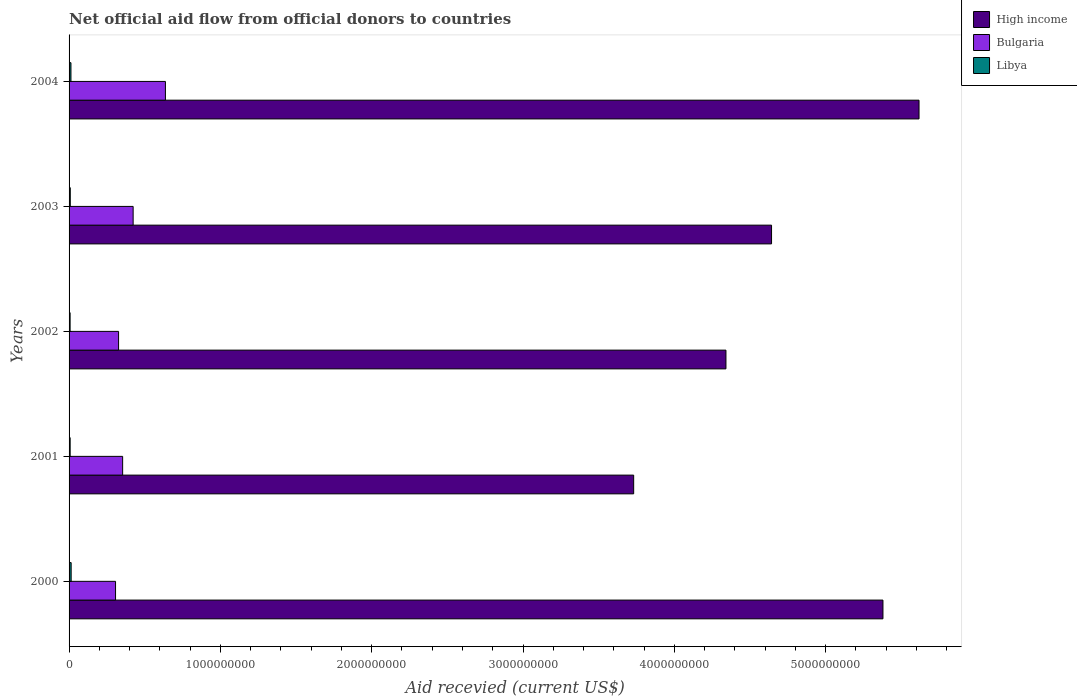How many different coloured bars are there?
Keep it short and to the point. 3. Are the number of bars on each tick of the Y-axis equal?
Ensure brevity in your answer.  Yes. How many bars are there on the 5th tick from the top?
Provide a succinct answer. 3. How many bars are there on the 3rd tick from the bottom?
Your response must be concise. 3. What is the label of the 5th group of bars from the top?
Provide a short and direct response. 2000. What is the total aid received in Bulgaria in 2000?
Make the answer very short. 3.07e+08. Across all years, what is the maximum total aid received in Bulgaria?
Make the answer very short. 6.37e+08. Across all years, what is the minimum total aid received in Libya?
Offer a terse response. 6.88e+06. In which year was the total aid received in Libya minimum?
Your response must be concise. 2002. What is the total total aid received in Libya in the graph?
Offer a terse response. 4.82e+07. What is the difference between the total aid received in High income in 2000 and that in 2004?
Offer a terse response. -2.38e+08. What is the difference between the total aid received in High income in 2001 and the total aid received in Bulgaria in 2002?
Offer a very short reply. 3.40e+09. What is the average total aid received in High income per year?
Provide a succinct answer. 4.74e+09. In the year 2004, what is the difference between the total aid received in Libya and total aid received in High income?
Make the answer very short. -5.60e+09. What is the ratio of the total aid received in High income in 2003 to that in 2004?
Provide a succinct answer. 0.83. Is the difference between the total aid received in Libya in 2002 and 2004 greater than the difference between the total aid received in High income in 2002 and 2004?
Your response must be concise. Yes. What is the difference between the highest and the second highest total aid received in Bulgaria?
Make the answer very short. 2.13e+08. What is the difference between the highest and the lowest total aid received in High income?
Keep it short and to the point. 1.89e+09. In how many years, is the total aid received in High income greater than the average total aid received in High income taken over all years?
Your answer should be very brief. 2. Is the sum of the total aid received in Libya in 2000 and 2003 greater than the maximum total aid received in High income across all years?
Your answer should be compact. No. What does the 1st bar from the top in 2002 represents?
Provide a succinct answer. Libya. What does the 2nd bar from the bottom in 2004 represents?
Your answer should be compact. Bulgaria. Are all the bars in the graph horizontal?
Offer a very short reply. Yes. How many years are there in the graph?
Keep it short and to the point. 5. What is the difference between two consecutive major ticks on the X-axis?
Offer a terse response. 1.00e+09. Are the values on the major ticks of X-axis written in scientific E-notation?
Your answer should be very brief. No. Does the graph contain any zero values?
Give a very brief answer. No. Does the graph contain grids?
Give a very brief answer. No. Where does the legend appear in the graph?
Offer a terse response. Top right. How are the legend labels stacked?
Provide a short and direct response. Vertical. What is the title of the graph?
Your answer should be very brief. Net official aid flow from official donors to countries. Does "South Africa" appear as one of the legend labels in the graph?
Give a very brief answer. No. What is the label or title of the X-axis?
Your response must be concise. Aid recevied (current US$). What is the label or title of the Y-axis?
Your answer should be compact. Years. What is the Aid recevied (current US$) in High income in 2000?
Ensure brevity in your answer.  5.38e+09. What is the Aid recevied (current US$) of Bulgaria in 2000?
Provide a succinct answer. 3.07e+08. What is the Aid recevied (current US$) of Libya in 2000?
Provide a succinct answer. 1.38e+07. What is the Aid recevied (current US$) of High income in 2001?
Offer a very short reply. 3.73e+09. What is the Aid recevied (current US$) in Bulgaria in 2001?
Offer a terse response. 3.54e+08. What is the Aid recevied (current US$) of Libya in 2001?
Ensure brevity in your answer.  7.14e+06. What is the Aid recevied (current US$) of High income in 2002?
Offer a very short reply. 4.34e+09. What is the Aid recevied (current US$) of Bulgaria in 2002?
Offer a terse response. 3.27e+08. What is the Aid recevied (current US$) of Libya in 2002?
Provide a succinct answer. 6.88e+06. What is the Aid recevied (current US$) of High income in 2003?
Provide a succinct answer. 4.64e+09. What is the Aid recevied (current US$) of Bulgaria in 2003?
Your answer should be compact. 4.23e+08. What is the Aid recevied (current US$) in Libya in 2003?
Ensure brevity in your answer.  7.95e+06. What is the Aid recevied (current US$) of High income in 2004?
Provide a succinct answer. 5.62e+09. What is the Aid recevied (current US$) of Bulgaria in 2004?
Provide a short and direct response. 6.37e+08. What is the Aid recevied (current US$) in Libya in 2004?
Provide a succinct answer. 1.24e+07. Across all years, what is the maximum Aid recevied (current US$) in High income?
Provide a succinct answer. 5.62e+09. Across all years, what is the maximum Aid recevied (current US$) in Bulgaria?
Offer a very short reply. 6.37e+08. Across all years, what is the maximum Aid recevied (current US$) of Libya?
Provide a short and direct response. 1.38e+07. Across all years, what is the minimum Aid recevied (current US$) in High income?
Your answer should be compact. 3.73e+09. Across all years, what is the minimum Aid recevied (current US$) in Bulgaria?
Provide a succinct answer. 3.07e+08. Across all years, what is the minimum Aid recevied (current US$) of Libya?
Ensure brevity in your answer.  6.88e+06. What is the total Aid recevied (current US$) in High income in the graph?
Your answer should be very brief. 2.37e+1. What is the total Aid recevied (current US$) of Bulgaria in the graph?
Ensure brevity in your answer.  2.05e+09. What is the total Aid recevied (current US$) in Libya in the graph?
Provide a succinct answer. 4.82e+07. What is the difference between the Aid recevied (current US$) in High income in 2000 and that in 2001?
Provide a succinct answer. 1.65e+09. What is the difference between the Aid recevied (current US$) in Bulgaria in 2000 and that in 2001?
Make the answer very short. -4.69e+07. What is the difference between the Aid recevied (current US$) of Libya in 2000 and that in 2001?
Your answer should be compact. 6.61e+06. What is the difference between the Aid recevied (current US$) of High income in 2000 and that in 2002?
Keep it short and to the point. 1.04e+09. What is the difference between the Aid recevied (current US$) of Bulgaria in 2000 and that in 2002?
Provide a short and direct response. -2.01e+07. What is the difference between the Aid recevied (current US$) of Libya in 2000 and that in 2002?
Your answer should be compact. 6.87e+06. What is the difference between the Aid recevied (current US$) in High income in 2000 and that in 2003?
Offer a terse response. 7.36e+08. What is the difference between the Aid recevied (current US$) in Bulgaria in 2000 and that in 2003?
Keep it short and to the point. -1.16e+08. What is the difference between the Aid recevied (current US$) in Libya in 2000 and that in 2003?
Your response must be concise. 5.80e+06. What is the difference between the Aid recevied (current US$) in High income in 2000 and that in 2004?
Offer a very short reply. -2.38e+08. What is the difference between the Aid recevied (current US$) in Bulgaria in 2000 and that in 2004?
Ensure brevity in your answer.  -3.30e+08. What is the difference between the Aid recevied (current US$) in Libya in 2000 and that in 2004?
Offer a terse response. 1.32e+06. What is the difference between the Aid recevied (current US$) of High income in 2001 and that in 2002?
Give a very brief answer. -6.10e+08. What is the difference between the Aid recevied (current US$) in Bulgaria in 2001 and that in 2002?
Provide a short and direct response. 2.68e+07. What is the difference between the Aid recevied (current US$) in Libya in 2001 and that in 2002?
Give a very brief answer. 2.60e+05. What is the difference between the Aid recevied (current US$) of High income in 2001 and that in 2003?
Offer a terse response. -9.11e+08. What is the difference between the Aid recevied (current US$) of Bulgaria in 2001 and that in 2003?
Offer a very short reply. -6.94e+07. What is the difference between the Aid recevied (current US$) in Libya in 2001 and that in 2003?
Offer a terse response. -8.10e+05. What is the difference between the Aid recevied (current US$) of High income in 2001 and that in 2004?
Offer a very short reply. -1.89e+09. What is the difference between the Aid recevied (current US$) of Bulgaria in 2001 and that in 2004?
Ensure brevity in your answer.  -2.83e+08. What is the difference between the Aid recevied (current US$) in Libya in 2001 and that in 2004?
Give a very brief answer. -5.29e+06. What is the difference between the Aid recevied (current US$) in High income in 2002 and that in 2003?
Make the answer very short. -3.01e+08. What is the difference between the Aid recevied (current US$) of Bulgaria in 2002 and that in 2003?
Offer a terse response. -9.62e+07. What is the difference between the Aid recevied (current US$) in Libya in 2002 and that in 2003?
Give a very brief answer. -1.07e+06. What is the difference between the Aid recevied (current US$) of High income in 2002 and that in 2004?
Ensure brevity in your answer.  -1.28e+09. What is the difference between the Aid recevied (current US$) in Bulgaria in 2002 and that in 2004?
Make the answer very short. -3.10e+08. What is the difference between the Aid recevied (current US$) in Libya in 2002 and that in 2004?
Give a very brief answer. -5.55e+06. What is the difference between the Aid recevied (current US$) of High income in 2003 and that in 2004?
Offer a very short reply. -9.75e+08. What is the difference between the Aid recevied (current US$) of Bulgaria in 2003 and that in 2004?
Your response must be concise. -2.13e+08. What is the difference between the Aid recevied (current US$) in Libya in 2003 and that in 2004?
Give a very brief answer. -4.48e+06. What is the difference between the Aid recevied (current US$) of High income in 2000 and the Aid recevied (current US$) of Bulgaria in 2001?
Offer a terse response. 5.02e+09. What is the difference between the Aid recevied (current US$) in High income in 2000 and the Aid recevied (current US$) in Libya in 2001?
Provide a short and direct response. 5.37e+09. What is the difference between the Aid recevied (current US$) of Bulgaria in 2000 and the Aid recevied (current US$) of Libya in 2001?
Give a very brief answer. 3.00e+08. What is the difference between the Aid recevied (current US$) of High income in 2000 and the Aid recevied (current US$) of Bulgaria in 2002?
Provide a succinct answer. 5.05e+09. What is the difference between the Aid recevied (current US$) of High income in 2000 and the Aid recevied (current US$) of Libya in 2002?
Your answer should be very brief. 5.37e+09. What is the difference between the Aid recevied (current US$) of Bulgaria in 2000 and the Aid recevied (current US$) of Libya in 2002?
Offer a very short reply. 3.00e+08. What is the difference between the Aid recevied (current US$) in High income in 2000 and the Aid recevied (current US$) in Bulgaria in 2003?
Make the answer very short. 4.96e+09. What is the difference between the Aid recevied (current US$) of High income in 2000 and the Aid recevied (current US$) of Libya in 2003?
Make the answer very short. 5.37e+09. What is the difference between the Aid recevied (current US$) of Bulgaria in 2000 and the Aid recevied (current US$) of Libya in 2003?
Ensure brevity in your answer.  2.99e+08. What is the difference between the Aid recevied (current US$) in High income in 2000 and the Aid recevied (current US$) in Bulgaria in 2004?
Your answer should be very brief. 4.74e+09. What is the difference between the Aid recevied (current US$) in High income in 2000 and the Aid recevied (current US$) in Libya in 2004?
Your answer should be compact. 5.37e+09. What is the difference between the Aid recevied (current US$) of Bulgaria in 2000 and the Aid recevied (current US$) of Libya in 2004?
Provide a succinct answer. 2.95e+08. What is the difference between the Aid recevied (current US$) of High income in 2001 and the Aid recevied (current US$) of Bulgaria in 2002?
Your answer should be compact. 3.40e+09. What is the difference between the Aid recevied (current US$) in High income in 2001 and the Aid recevied (current US$) in Libya in 2002?
Your response must be concise. 3.72e+09. What is the difference between the Aid recevied (current US$) in Bulgaria in 2001 and the Aid recevied (current US$) in Libya in 2002?
Your answer should be very brief. 3.47e+08. What is the difference between the Aid recevied (current US$) of High income in 2001 and the Aid recevied (current US$) of Bulgaria in 2003?
Your response must be concise. 3.31e+09. What is the difference between the Aid recevied (current US$) of High income in 2001 and the Aid recevied (current US$) of Libya in 2003?
Provide a short and direct response. 3.72e+09. What is the difference between the Aid recevied (current US$) in Bulgaria in 2001 and the Aid recevied (current US$) in Libya in 2003?
Make the answer very short. 3.46e+08. What is the difference between the Aid recevied (current US$) of High income in 2001 and the Aid recevied (current US$) of Bulgaria in 2004?
Keep it short and to the point. 3.09e+09. What is the difference between the Aid recevied (current US$) in High income in 2001 and the Aid recevied (current US$) in Libya in 2004?
Ensure brevity in your answer.  3.72e+09. What is the difference between the Aid recevied (current US$) in Bulgaria in 2001 and the Aid recevied (current US$) in Libya in 2004?
Ensure brevity in your answer.  3.42e+08. What is the difference between the Aid recevied (current US$) of High income in 2002 and the Aid recevied (current US$) of Bulgaria in 2003?
Make the answer very short. 3.92e+09. What is the difference between the Aid recevied (current US$) in High income in 2002 and the Aid recevied (current US$) in Libya in 2003?
Your answer should be very brief. 4.33e+09. What is the difference between the Aid recevied (current US$) of Bulgaria in 2002 and the Aid recevied (current US$) of Libya in 2003?
Keep it short and to the point. 3.19e+08. What is the difference between the Aid recevied (current US$) of High income in 2002 and the Aid recevied (current US$) of Bulgaria in 2004?
Ensure brevity in your answer.  3.70e+09. What is the difference between the Aid recevied (current US$) of High income in 2002 and the Aid recevied (current US$) of Libya in 2004?
Provide a succinct answer. 4.33e+09. What is the difference between the Aid recevied (current US$) of Bulgaria in 2002 and the Aid recevied (current US$) of Libya in 2004?
Ensure brevity in your answer.  3.15e+08. What is the difference between the Aid recevied (current US$) in High income in 2003 and the Aid recevied (current US$) in Bulgaria in 2004?
Offer a very short reply. 4.01e+09. What is the difference between the Aid recevied (current US$) of High income in 2003 and the Aid recevied (current US$) of Libya in 2004?
Provide a short and direct response. 4.63e+09. What is the difference between the Aid recevied (current US$) of Bulgaria in 2003 and the Aid recevied (current US$) of Libya in 2004?
Ensure brevity in your answer.  4.11e+08. What is the average Aid recevied (current US$) in High income per year?
Offer a very short reply. 4.74e+09. What is the average Aid recevied (current US$) of Bulgaria per year?
Your response must be concise. 4.10e+08. What is the average Aid recevied (current US$) of Libya per year?
Make the answer very short. 9.63e+06. In the year 2000, what is the difference between the Aid recevied (current US$) of High income and Aid recevied (current US$) of Bulgaria?
Provide a succinct answer. 5.07e+09. In the year 2000, what is the difference between the Aid recevied (current US$) in High income and Aid recevied (current US$) in Libya?
Offer a terse response. 5.37e+09. In the year 2000, what is the difference between the Aid recevied (current US$) of Bulgaria and Aid recevied (current US$) of Libya?
Make the answer very short. 2.93e+08. In the year 2001, what is the difference between the Aid recevied (current US$) of High income and Aid recevied (current US$) of Bulgaria?
Ensure brevity in your answer.  3.38e+09. In the year 2001, what is the difference between the Aid recevied (current US$) of High income and Aid recevied (current US$) of Libya?
Provide a short and direct response. 3.72e+09. In the year 2001, what is the difference between the Aid recevied (current US$) in Bulgaria and Aid recevied (current US$) in Libya?
Your answer should be very brief. 3.47e+08. In the year 2002, what is the difference between the Aid recevied (current US$) in High income and Aid recevied (current US$) in Bulgaria?
Ensure brevity in your answer.  4.01e+09. In the year 2002, what is the difference between the Aid recevied (current US$) of High income and Aid recevied (current US$) of Libya?
Your answer should be compact. 4.33e+09. In the year 2002, what is the difference between the Aid recevied (current US$) in Bulgaria and Aid recevied (current US$) in Libya?
Provide a succinct answer. 3.20e+08. In the year 2003, what is the difference between the Aid recevied (current US$) of High income and Aid recevied (current US$) of Bulgaria?
Provide a short and direct response. 4.22e+09. In the year 2003, what is the difference between the Aid recevied (current US$) of High income and Aid recevied (current US$) of Libya?
Your answer should be compact. 4.63e+09. In the year 2003, what is the difference between the Aid recevied (current US$) in Bulgaria and Aid recevied (current US$) in Libya?
Your response must be concise. 4.15e+08. In the year 2004, what is the difference between the Aid recevied (current US$) in High income and Aid recevied (current US$) in Bulgaria?
Give a very brief answer. 4.98e+09. In the year 2004, what is the difference between the Aid recevied (current US$) of High income and Aid recevied (current US$) of Libya?
Provide a short and direct response. 5.60e+09. In the year 2004, what is the difference between the Aid recevied (current US$) of Bulgaria and Aid recevied (current US$) of Libya?
Your response must be concise. 6.24e+08. What is the ratio of the Aid recevied (current US$) of High income in 2000 to that in 2001?
Your answer should be very brief. 1.44. What is the ratio of the Aid recevied (current US$) in Bulgaria in 2000 to that in 2001?
Give a very brief answer. 0.87. What is the ratio of the Aid recevied (current US$) in Libya in 2000 to that in 2001?
Keep it short and to the point. 1.93. What is the ratio of the Aid recevied (current US$) of High income in 2000 to that in 2002?
Your answer should be compact. 1.24. What is the ratio of the Aid recevied (current US$) of Bulgaria in 2000 to that in 2002?
Ensure brevity in your answer.  0.94. What is the ratio of the Aid recevied (current US$) of Libya in 2000 to that in 2002?
Provide a succinct answer. 2. What is the ratio of the Aid recevied (current US$) of High income in 2000 to that in 2003?
Your response must be concise. 1.16. What is the ratio of the Aid recevied (current US$) of Bulgaria in 2000 to that in 2003?
Offer a terse response. 0.73. What is the ratio of the Aid recevied (current US$) of Libya in 2000 to that in 2003?
Provide a succinct answer. 1.73. What is the ratio of the Aid recevied (current US$) of High income in 2000 to that in 2004?
Provide a short and direct response. 0.96. What is the ratio of the Aid recevied (current US$) in Bulgaria in 2000 to that in 2004?
Ensure brevity in your answer.  0.48. What is the ratio of the Aid recevied (current US$) in Libya in 2000 to that in 2004?
Offer a very short reply. 1.11. What is the ratio of the Aid recevied (current US$) in High income in 2001 to that in 2002?
Make the answer very short. 0.86. What is the ratio of the Aid recevied (current US$) in Bulgaria in 2001 to that in 2002?
Your answer should be compact. 1.08. What is the ratio of the Aid recevied (current US$) of Libya in 2001 to that in 2002?
Offer a very short reply. 1.04. What is the ratio of the Aid recevied (current US$) of High income in 2001 to that in 2003?
Provide a succinct answer. 0.8. What is the ratio of the Aid recevied (current US$) in Bulgaria in 2001 to that in 2003?
Your answer should be very brief. 0.84. What is the ratio of the Aid recevied (current US$) of Libya in 2001 to that in 2003?
Ensure brevity in your answer.  0.9. What is the ratio of the Aid recevied (current US$) in High income in 2001 to that in 2004?
Keep it short and to the point. 0.66. What is the ratio of the Aid recevied (current US$) in Bulgaria in 2001 to that in 2004?
Your answer should be very brief. 0.56. What is the ratio of the Aid recevied (current US$) in Libya in 2001 to that in 2004?
Ensure brevity in your answer.  0.57. What is the ratio of the Aid recevied (current US$) in High income in 2002 to that in 2003?
Provide a short and direct response. 0.94. What is the ratio of the Aid recevied (current US$) in Bulgaria in 2002 to that in 2003?
Make the answer very short. 0.77. What is the ratio of the Aid recevied (current US$) of Libya in 2002 to that in 2003?
Keep it short and to the point. 0.87. What is the ratio of the Aid recevied (current US$) of High income in 2002 to that in 2004?
Offer a terse response. 0.77. What is the ratio of the Aid recevied (current US$) of Bulgaria in 2002 to that in 2004?
Give a very brief answer. 0.51. What is the ratio of the Aid recevied (current US$) in Libya in 2002 to that in 2004?
Provide a short and direct response. 0.55. What is the ratio of the Aid recevied (current US$) in High income in 2003 to that in 2004?
Ensure brevity in your answer.  0.83. What is the ratio of the Aid recevied (current US$) in Bulgaria in 2003 to that in 2004?
Ensure brevity in your answer.  0.67. What is the ratio of the Aid recevied (current US$) of Libya in 2003 to that in 2004?
Your answer should be compact. 0.64. What is the difference between the highest and the second highest Aid recevied (current US$) in High income?
Your response must be concise. 2.38e+08. What is the difference between the highest and the second highest Aid recevied (current US$) of Bulgaria?
Offer a very short reply. 2.13e+08. What is the difference between the highest and the second highest Aid recevied (current US$) in Libya?
Make the answer very short. 1.32e+06. What is the difference between the highest and the lowest Aid recevied (current US$) in High income?
Ensure brevity in your answer.  1.89e+09. What is the difference between the highest and the lowest Aid recevied (current US$) in Bulgaria?
Ensure brevity in your answer.  3.30e+08. What is the difference between the highest and the lowest Aid recevied (current US$) of Libya?
Your response must be concise. 6.87e+06. 